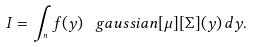<formula> <loc_0><loc_0><loc_500><loc_500>I = \int _ { \real ^ { n } } f ( y ) \, \ g a u s s i a n [ \mu ] [ \Sigma ] ( y ) \, d y .</formula> 